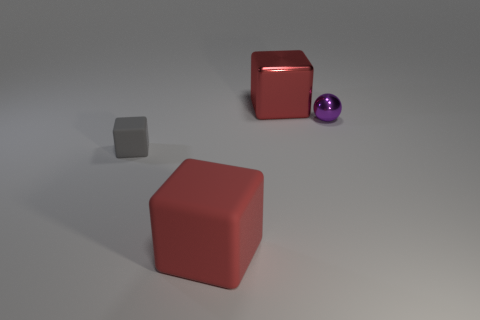Is the size of the red metallic block the same as the sphere?
Make the answer very short. No. There is a thing that is the same material as the gray cube; what size is it?
Keep it short and to the point. Large. What number of things have the same color as the ball?
Ensure brevity in your answer.  0. Is the number of large matte cubes that are to the right of the large rubber cube less than the number of tiny gray rubber blocks on the right side of the tiny gray cube?
Keep it short and to the point. No. Is the shape of the small object that is on the left side of the red shiny block the same as  the tiny purple thing?
Your response must be concise. No. Is there anything else that is the same material as the small purple sphere?
Provide a succinct answer. Yes. Is the material of the red thing right of the red rubber thing the same as the gray block?
Your answer should be very brief. No. What material is the large red cube left of the red object that is behind the large thing on the left side of the big metallic object?
Your answer should be compact. Rubber. How many other things are there of the same shape as the tiny gray thing?
Ensure brevity in your answer.  2. The large thing on the right side of the big rubber thing is what color?
Keep it short and to the point. Red. 